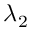Convert formula to latex. <formula><loc_0><loc_0><loc_500><loc_500>\lambda _ { 2 }</formula> 